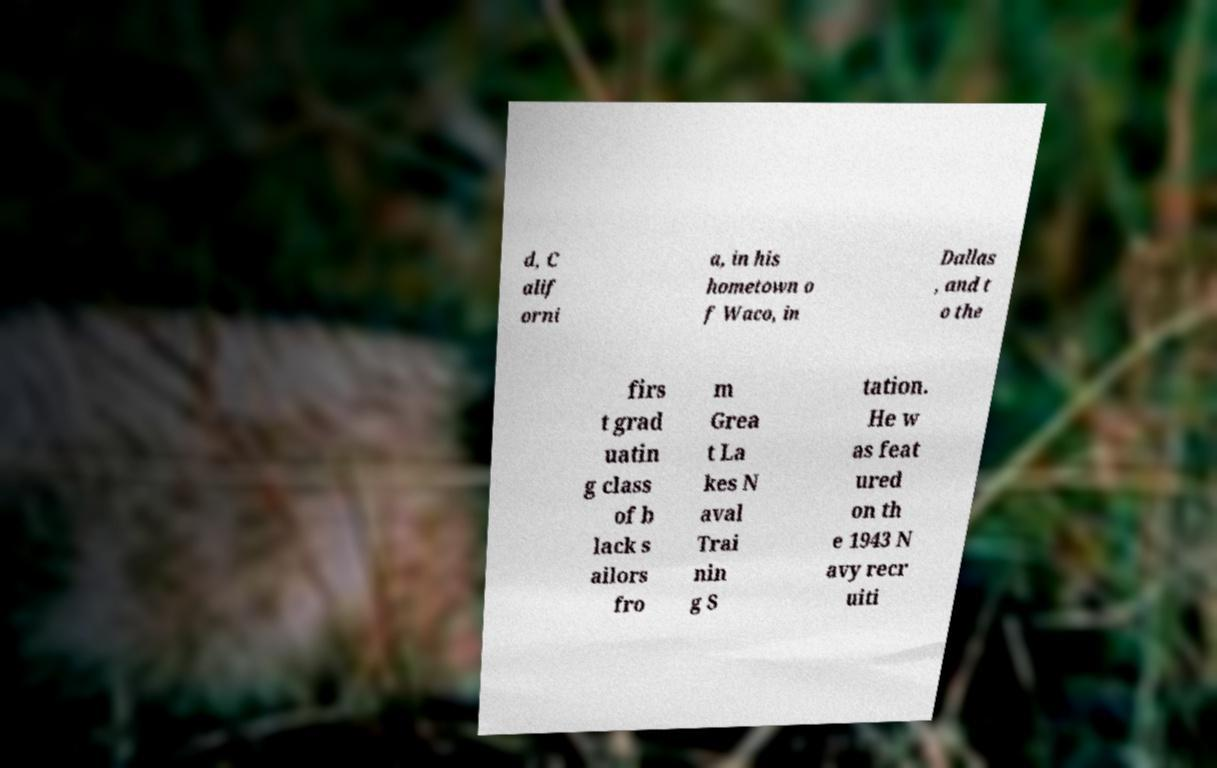What messages or text are displayed in this image? I need them in a readable, typed format. d, C alif orni a, in his hometown o f Waco, in Dallas , and t o the firs t grad uatin g class of b lack s ailors fro m Grea t La kes N aval Trai nin g S tation. He w as feat ured on th e 1943 N avy recr uiti 